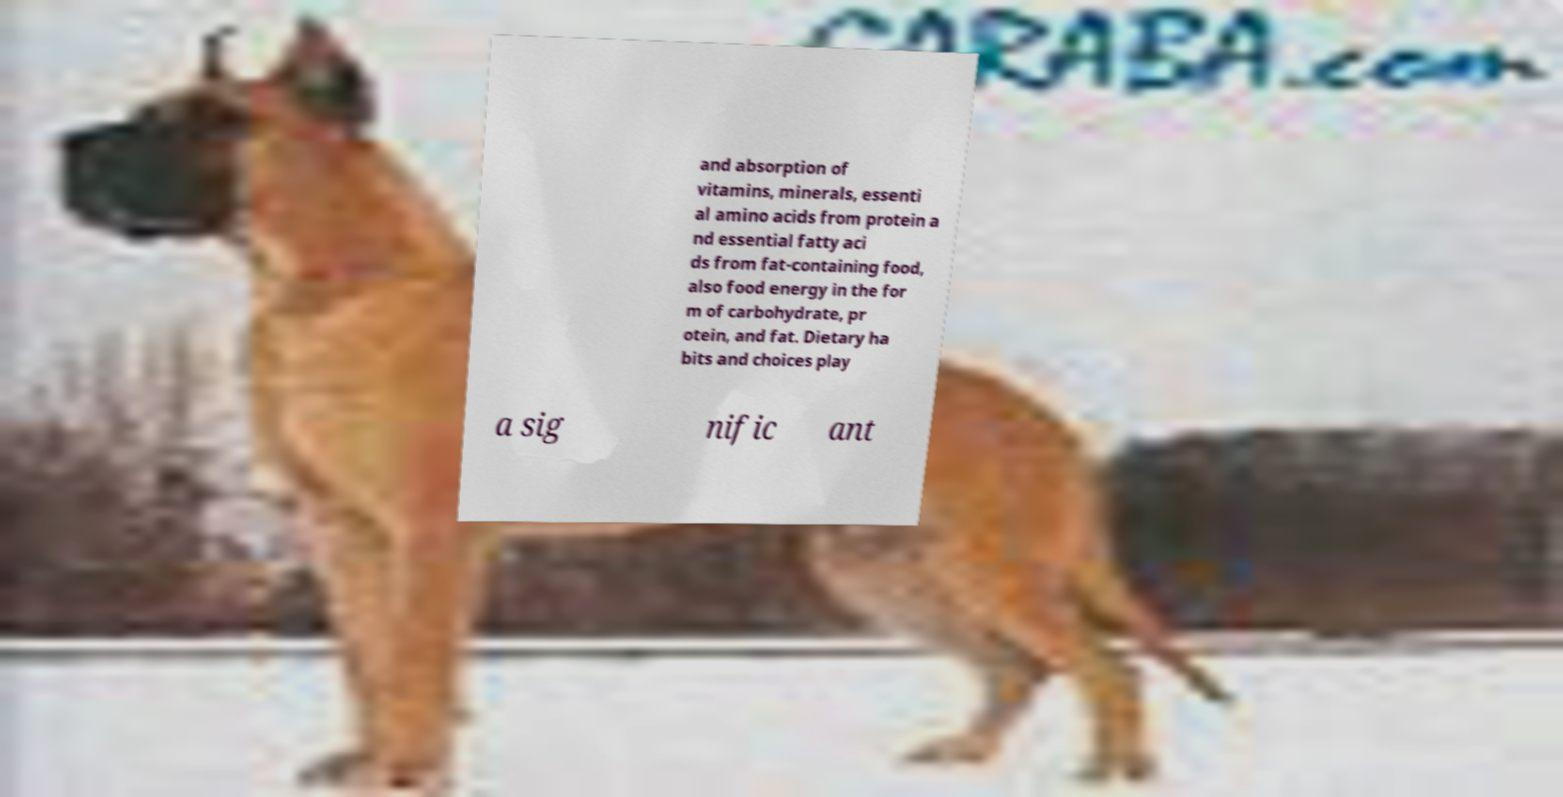Could you extract and type out the text from this image? and absorption of vitamins, minerals, essenti al amino acids from protein a nd essential fatty aci ds from fat-containing food, also food energy in the for m of carbohydrate, pr otein, and fat. Dietary ha bits and choices play a sig nific ant 